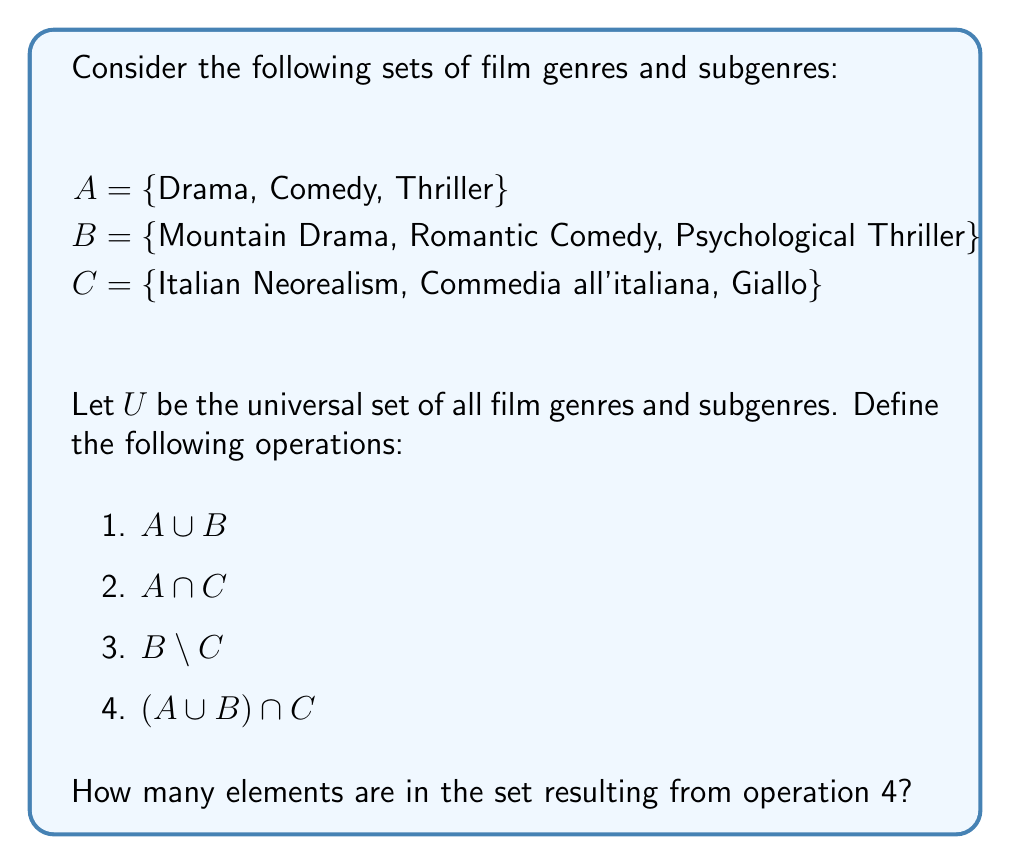Give your solution to this math problem. Let's approach this step-by-step:

1. First, let's calculate $A \cup B$:
   $A \cup B = \text{\{Drama, Comedy, Thriller, Mountain Drama, Romantic Comedy, Psychological Thriller\}}$

2. Now, let's find $A \cap C$:
   $A \cap C = \text{\{\}}$ (empty set, as there are no common elements)

3. For $B \setminus C$:
   $B \setminus C = \text{\{Mountain Drama, Romantic Comedy, Psychological Thriller\}}$ (all elements of B, as none are in C)

4. Now, for $(A \cup B) \cap C$:
   - We already calculated $A \cup B$ in step 1.
   - We need to find the intersection of this set with C.
   - $(A \cup B) \cap C = \text{\{Drama, Comedy, Thriller, Mountain Drama, Romantic Comedy, Psychological Thriller\}} \cap \text{\{Italian Neorealism, Commedia all'italiana, Giallo\}}$
   - There are no common elements between these sets.

Therefore, $(A \cup B) \cap C = \text{\{\}}$ (empty set)

The number of elements in an empty set is 0.
Answer: 0 